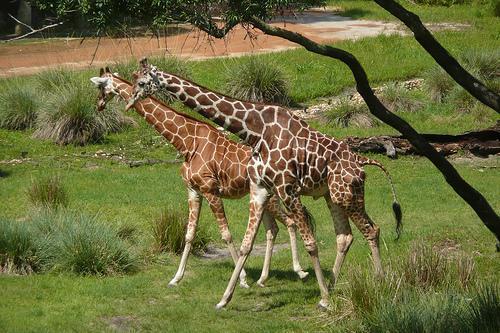How many fallen tree branches are there?
Give a very brief answer. 1. How many giraffe?
Give a very brief answer. 2. How many different colors on the giraffe body?
Give a very brief answer. 2. How many large tufts of grass are in the foreground?
Give a very brief answer. 1. How many giraffes are there?
Give a very brief answer. 2. 